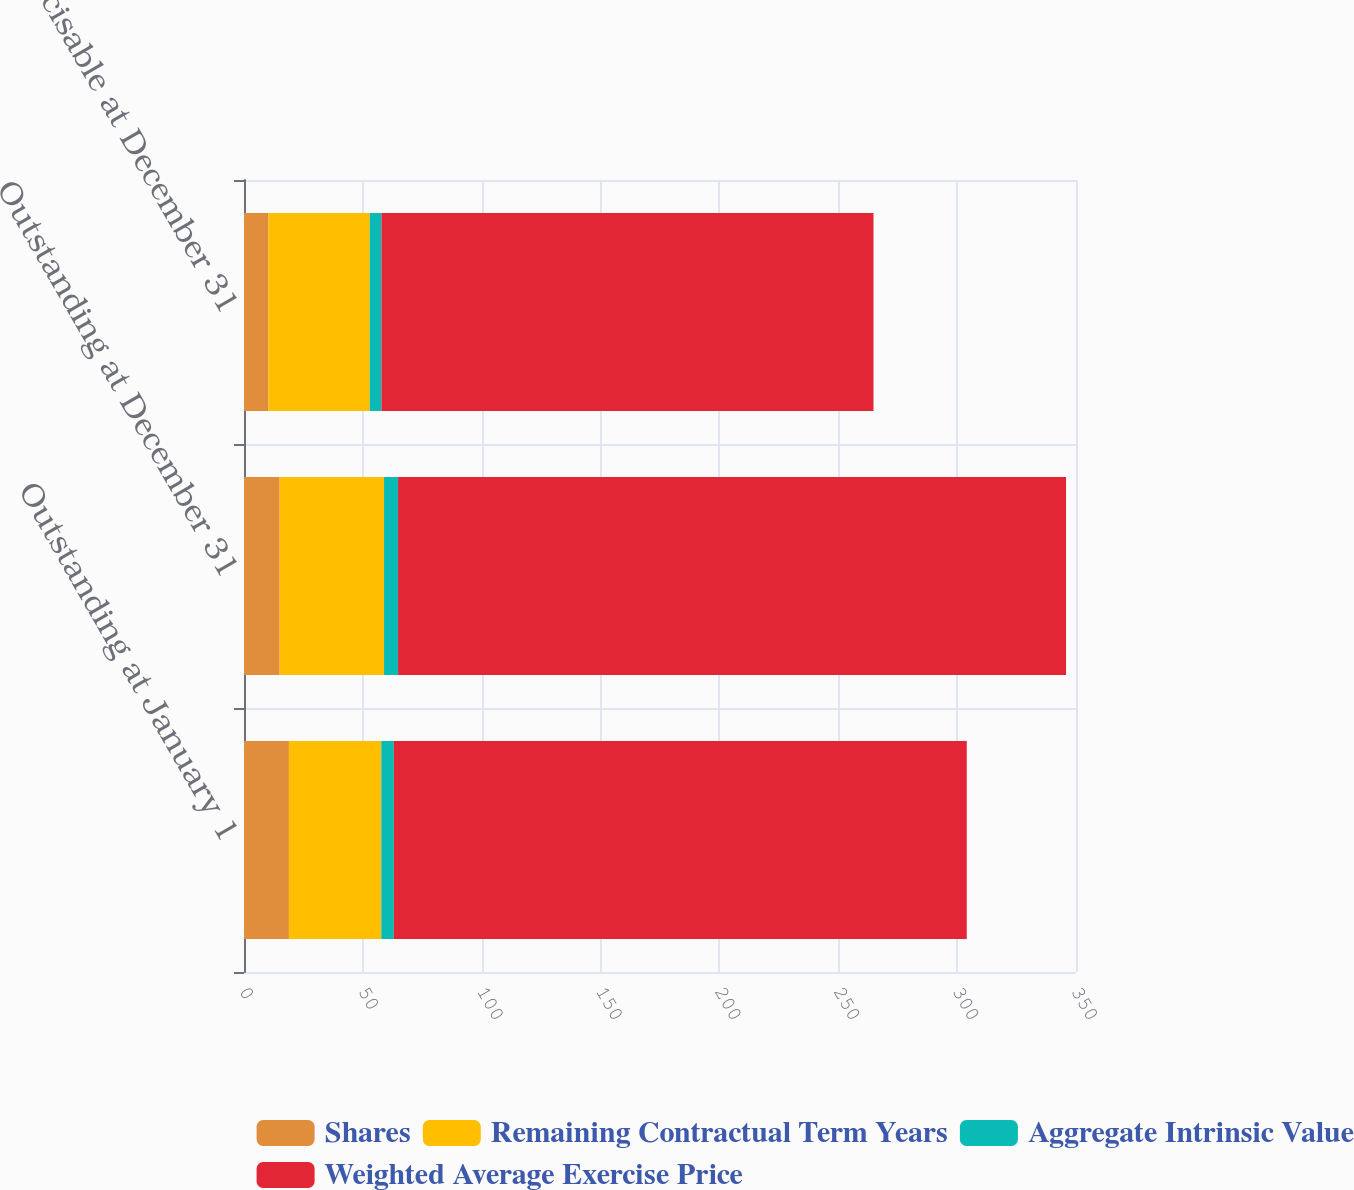Convert chart. <chart><loc_0><loc_0><loc_500><loc_500><stacked_bar_chart><ecel><fcel>Outstanding at January 1<fcel>Outstanding at December 31<fcel>Exercisable at December 31<nl><fcel>Shares<fcel>18.9<fcel>15<fcel>10.3<nl><fcel>Remaining Contractual Term Years<fcel>38.85<fcel>43.91<fcel>42.61<nl><fcel>Aggregate Intrinsic Value<fcel>5.3<fcel>5.9<fcel>4.9<nl><fcel>Weighted Average Exercise Price<fcel>241<fcel>281<fcel>207<nl></chart> 